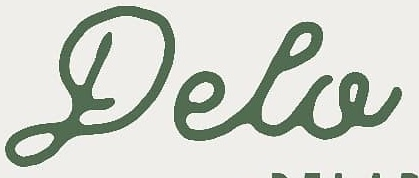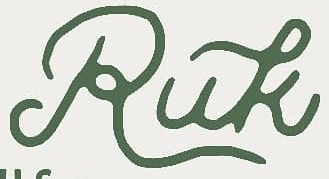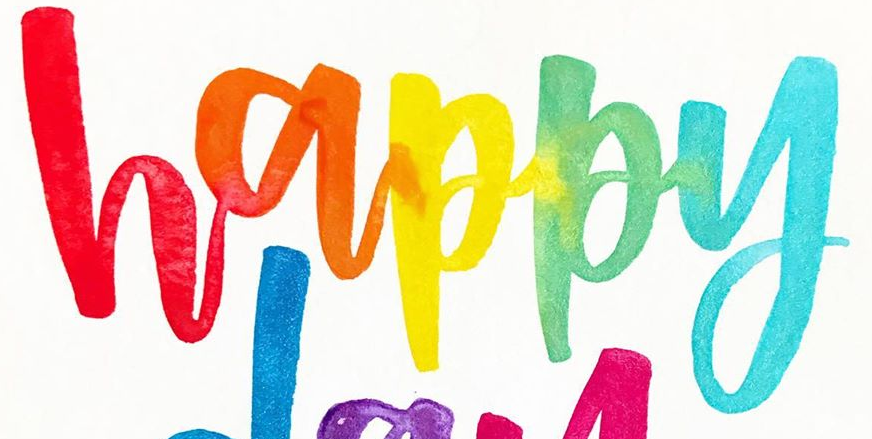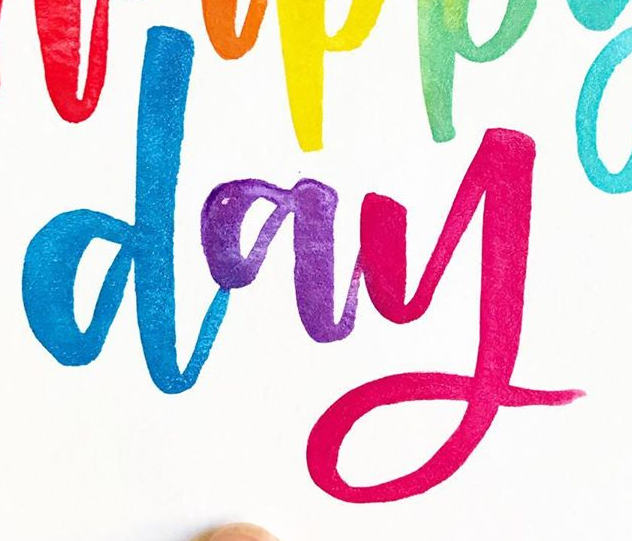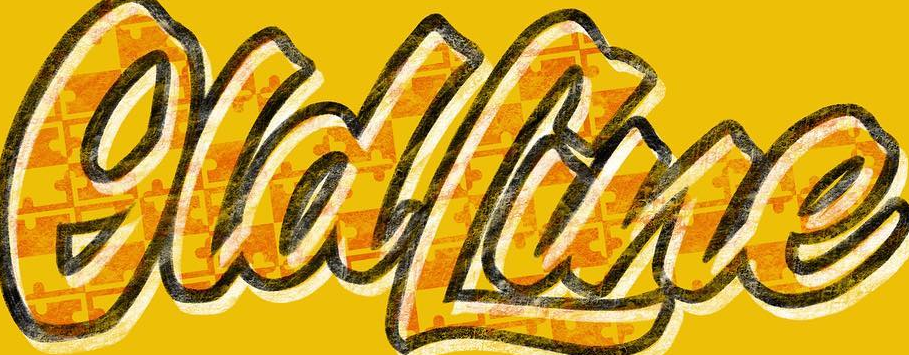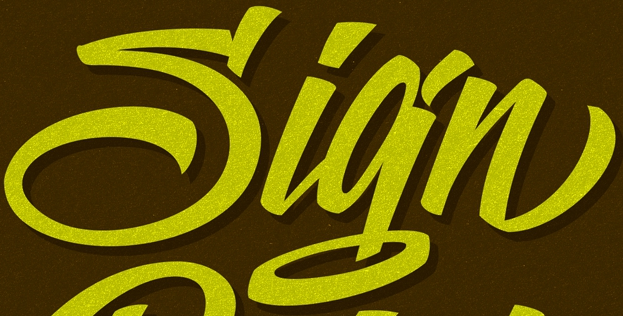What words are shown in these images in order, separated by a semicolon? Pela; Ruk; happy; day; OldLine; Sign 